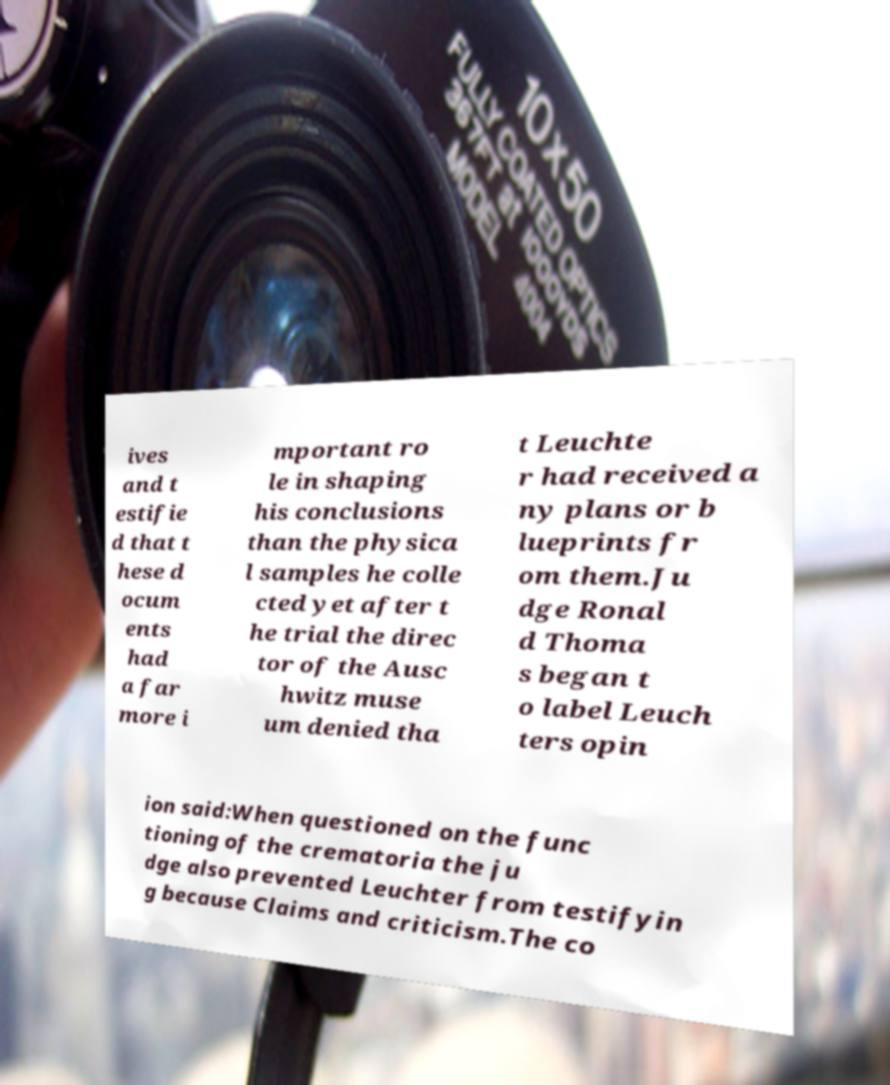Can you accurately transcribe the text from the provided image for me? ives and t estifie d that t hese d ocum ents had a far more i mportant ro le in shaping his conclusions than the physica l samples he colle cted yet after t he trial the direc tor of the Ausc hwitz muse um denied tha t Leuchte r had received a ny plans or b lueprints fr om them.Ju dge Ronal d Thoma s began t o label Leuch ters opin ion said:When questioned on the func tioning of the crematoria the ju dge also prevented Leuchter from testifyin g because Claims and criticism.The co 